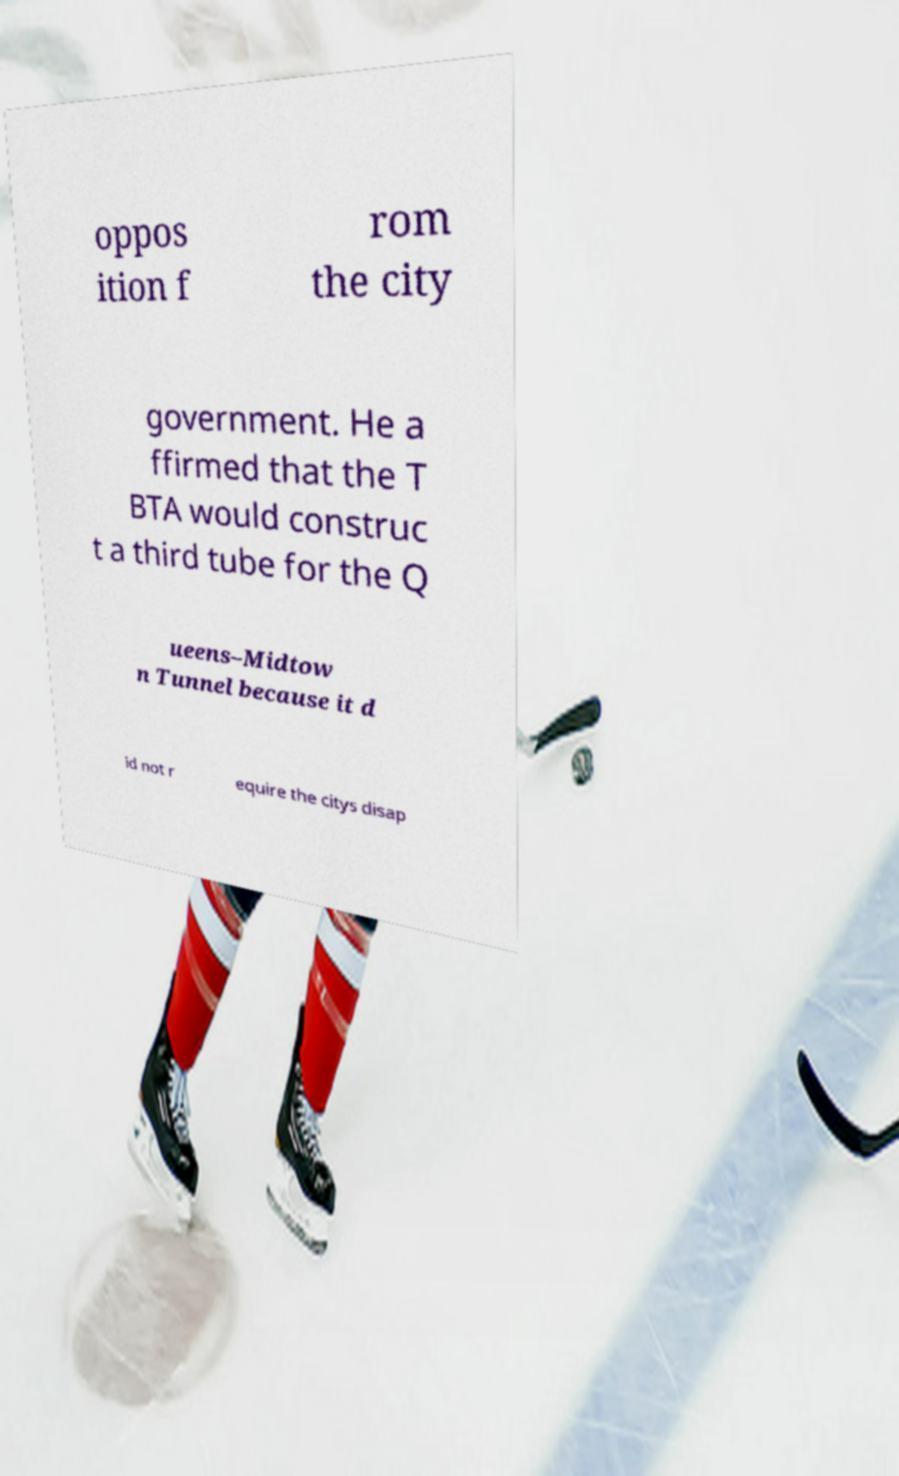Can you accurately transcribe the text from the provided image for me? oppos ition f rom the city government. He a ffirmed that the T BTA would construc t a third tube for the Q ueens–Midtow n Tunnel because it d id not r equire the citys disap 